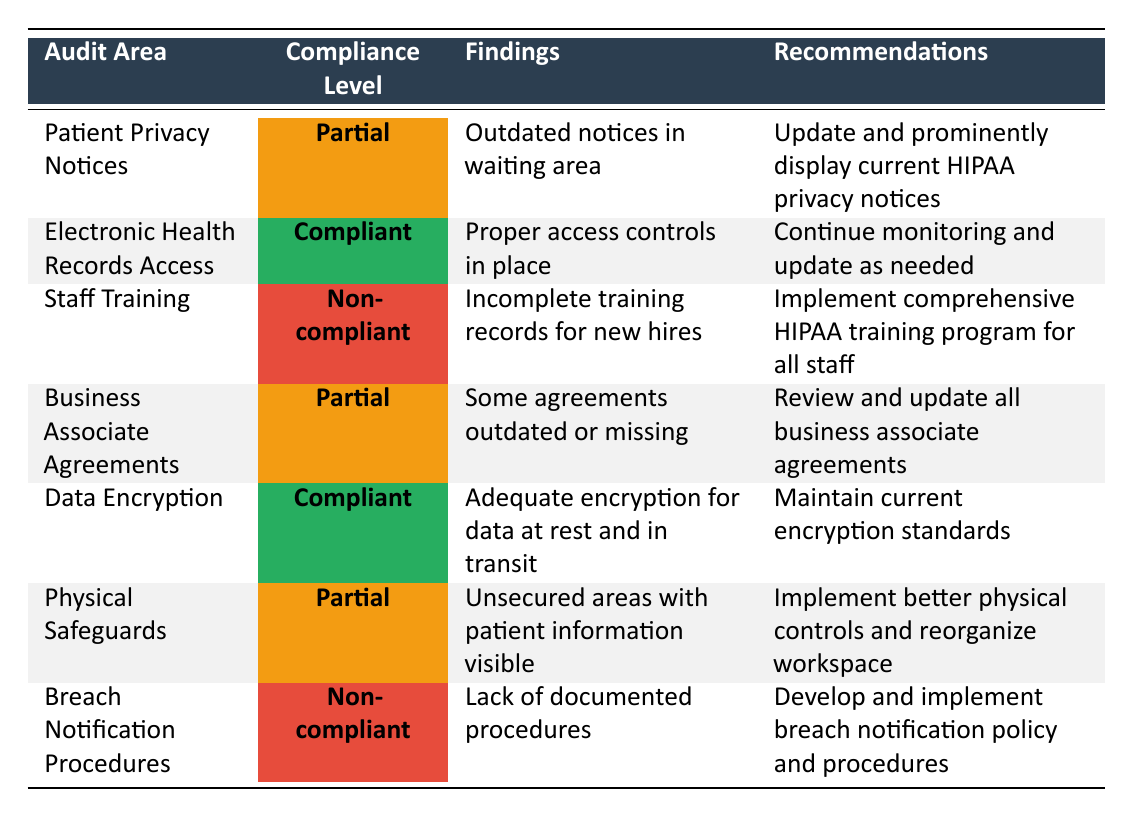What is the compliance level for Electronic Health Records Access? The table shows the compliance level for Electronic Health Records Access as "Compliant" in the corresponding row.
Answer: Compliant How many audit areas have a compliance level of Non-compliant? The table includes two rows marked as Non-compliant (Staff Training and Breach Notification Procedures). Therefore, there are 2 audit areas with a Non-compliant level.
Answer: 2 Is there a recommendation linked to the findings for Patient Privacy Notices? The table provides a specific recommendation for the findings relating to Patient Privacy Notices, which is to update and prominently display current HIPAA privacy notices. Therefore, the answer is yes.
Answer: Yes What is the finding related to Physical Safeguards? The table indicates that the finding related to Physical Safeguards is "Unsecured areas with patient information visible." This is directly stated in the relevant row.
Answer: Unsecured areas with patient information visible Can you list the compliance levels in ascending order? The compliance levels in the table are Non-compliant, Partial, and Compliant. Arranging these in ascending order results in: Non-compliant, Partial, Compliant.
Answer: Non-compliant, Partial, Compliant What are the recommendations for Business Associate Agreements? The table states the recommendation for Business Associate Agreements is to "Review and update all business associate agreements." This is explicitly mentioned in the corresponding row.
Answer: Review and update all business associate agreements How many audit areas are compliant or partially compliant? By counting the rows, we find that there are 3 compliant areas (Electronic Health Records Access, Data Encryption) and 3 partial areas (Patient Privacy Notices, Business Associate Agreements, Physical Safeguards), totaling 6 audit areas that are either compliant or partially compliant.
Answer: 6 What steps should be taken to address the non-compliance of Breach Notification Procedures? The recommendation given in the table for addressing the non-compliance of Breach Notification Procedures states that a breach notification policy and procedures should be developed and implemented. This is derived directly from the recommendation provided in the row.
Answer: Develop and implement breach notification policy and procedures Is the finding for Data Encryption compliant or non-compliant? According to the table, the finding for Data Encryption is marked as "Compliant" which is explicitly stated in the compliance level column for that row.
Answer: Compliant 